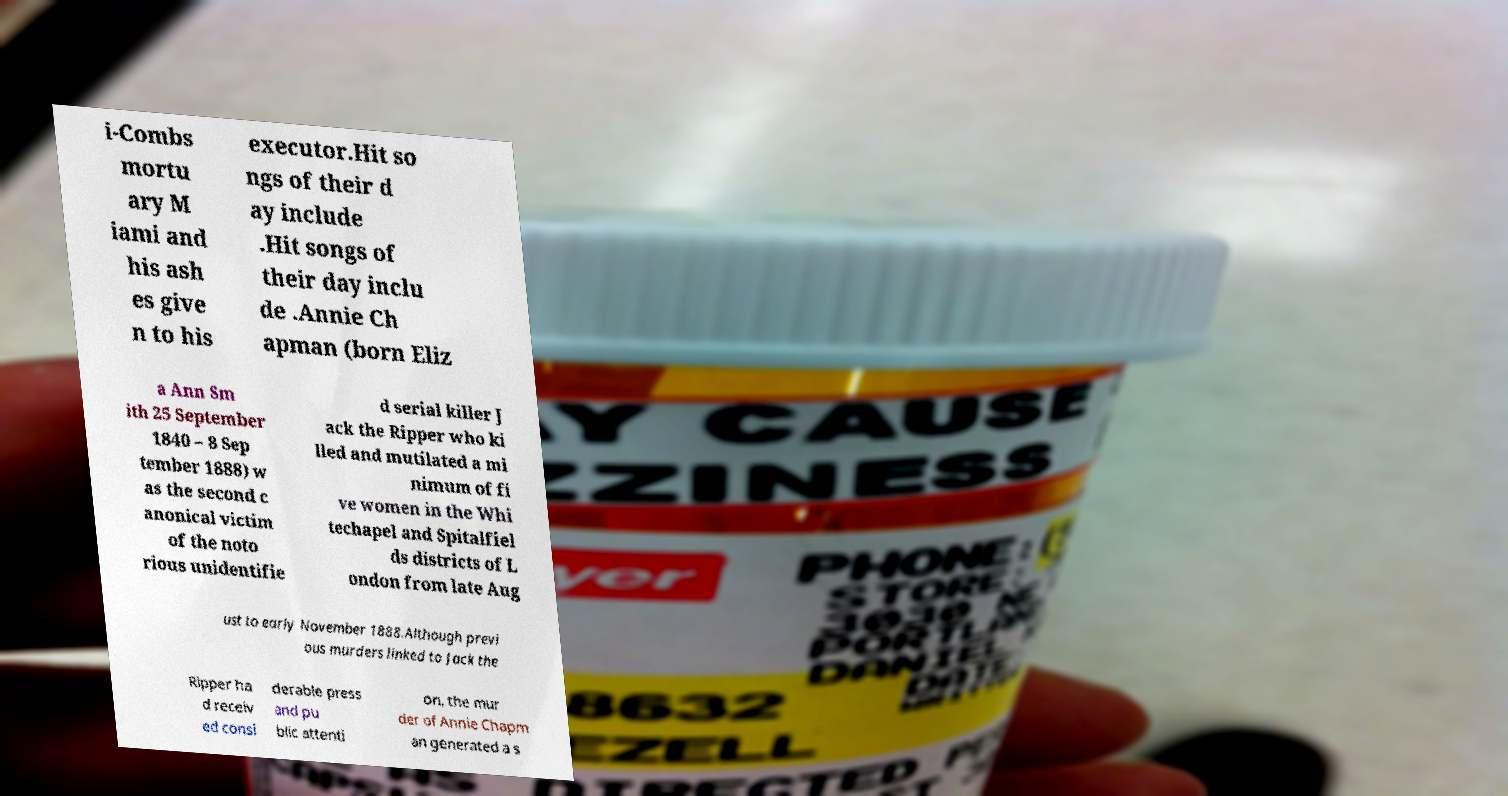Can you read and provide the text displayed in the image?This photo seems to have some interesting text. Can you extract and type it out for me? i-Combs mortu ary M iami and his ash es give n to his executor.Hit so ngs of their d ay include .Hit songs of their day inclu de .Annie Ch apman (born Eliz a Ann Sm ith 25 September 1840 – 8 Sep tember 1888) w as the second c anonical victim of the noto rious unidentifie d serial killer J ack the Ripper who ki lled and mutilated a mi nimum of fi ve women in the Whi techapel and Spitalfiel ds districts of L ondon from late Aug ust to early November 1888.Although previ ous murders linked to Jack the Ripper ha d receiv ed consi derable press and pu blic attenti on, the mur der of Annie Chapm an generated a s 